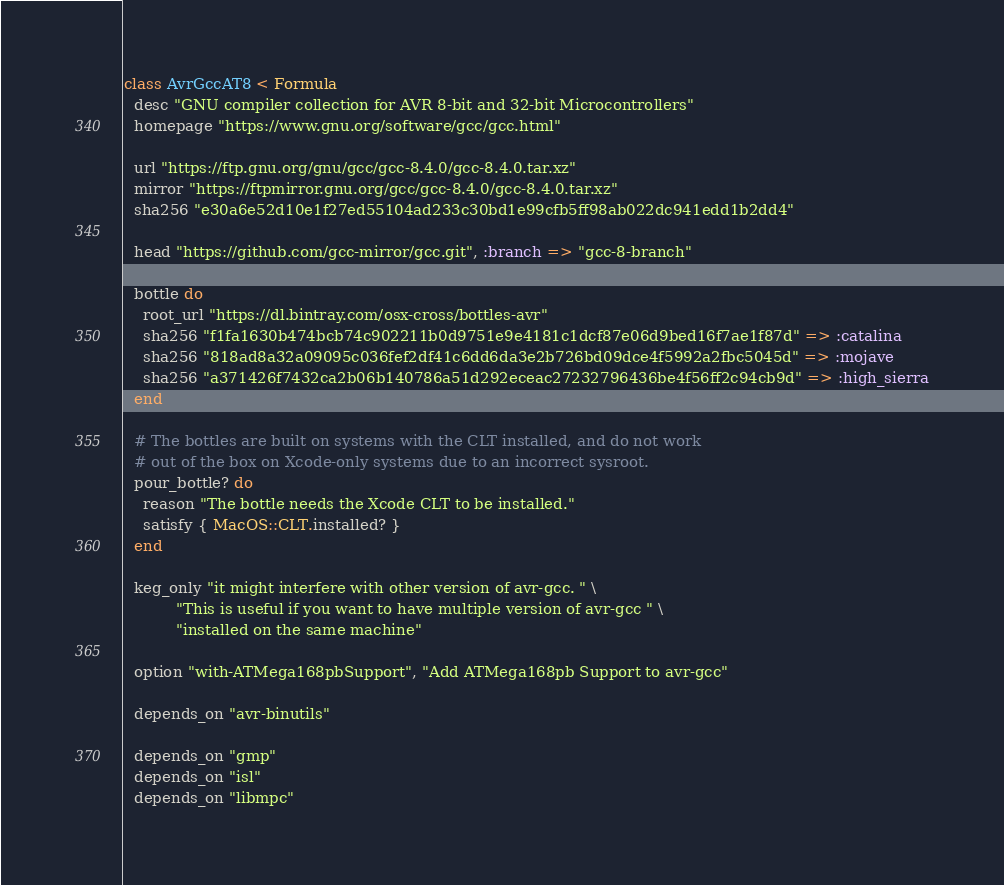<code> <loc_0><loc_0><loc_500><loc_500><_Ruby_>class AvrGccAT8 < Formula
  desc "GNU compiler collection for AVR 8-bit and 32-bit Microcontrollers"
  homepage "https://www.gnu.org/software/gcc/gcc.html"

  url "https://ftp.gnu.org/gnu/gcc/gcc-8.4.0/gcc-8.4.0.tar.xz"
  mirror "https://ftpmirror.gnu.org/gcc/gcc-8.4.0/gcc-8.4.0.tar.xz"
  sha256 "e30a6e52d10e1f27ed55104ad233c30bd1e99cfb5ff98ab022dc941edd1b2dd4"

  head "https://github.com/gcc-mirror/gcc.git", :branch => "gcc-8-branch"

  bottle do
    root_url "https://dl.bintray.com/osx-cross/bottles-avr"
    sha256 "f1fa1630b474bcb74c902211b0d9751e9e4181c1dcf87e06d9bed16f7ae1f87d" => :catalina
    sha256 "818ad8a32a09095c036fef2df41c6dd6da3e2b726bd09dce4f5992a2fbc5045d" => :mojave
    sha256 "a371426f7432ca2b06b140786a51d292eceac27232796436be4f56ff2c94cb9d" => :high_sierra
  end

  # The bottles are built on systems with the CLT installed, and do not work
  # out of the box on Xcode-only systems due to an incorrect sysroot.
  pour_bottle? do
    reason "The bottle needs the Xcode CLT to be installed."
    satisfy { MacOS::CLT.installed? }
  end

  keg_only "it might interfere with other version of avr-gcc. " \
           "This is useful if you want to have multiple version of avr-gcc " \
           "installed on the same machine"

  option "with-ATMega168pbSupport", "Add ATMega168pb Support to avr-gcc"

  depends_on "avr-binutils"

  depends_on "gmp"
  depends_on "isl"
  depends_on "libmpc"</code> 